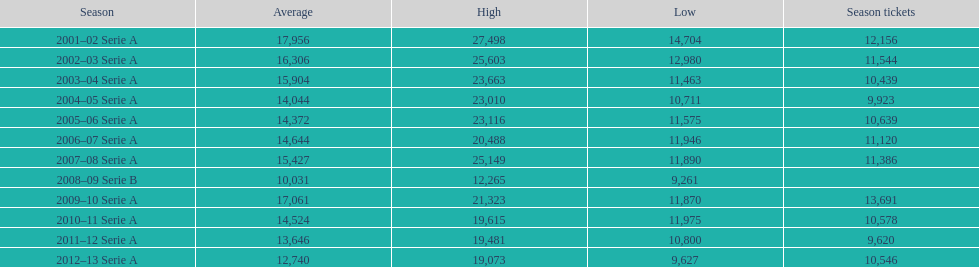What was the average in 2001 17,956. 